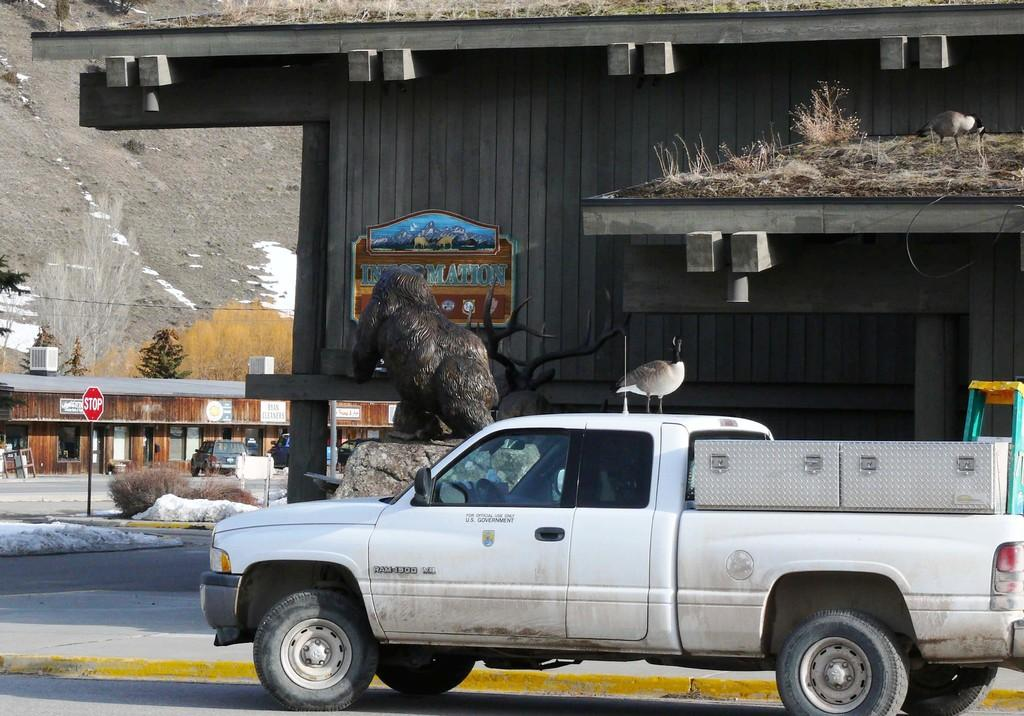What type of vehicle is on the road in the image? There is a white vehicle on the road in the image. What is located beside the vehicle? There is a wooden building beside the vehicle. What else can be seen in the background of the image? There are other objects visible in the background. How many frogs are sitting on the map in the image? There is no map or frogs present in the image. 